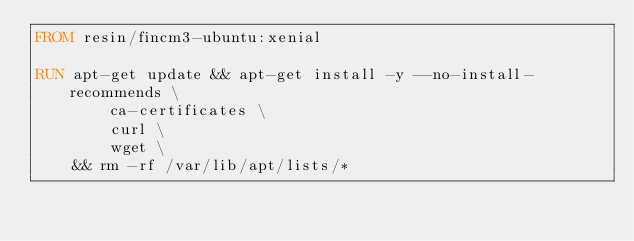<code> <loc_0><loc_0><loc_500><loc_500><_Dockerfile_>FROM resin/fincm3-ubuntu:xenial

RUN apt-get update && apt-get install -y --no-install-recommends \
		ca-certificates \
		curl \
		wget \
	&& rm -rf /var/lib/apt/lists/*
</code> 